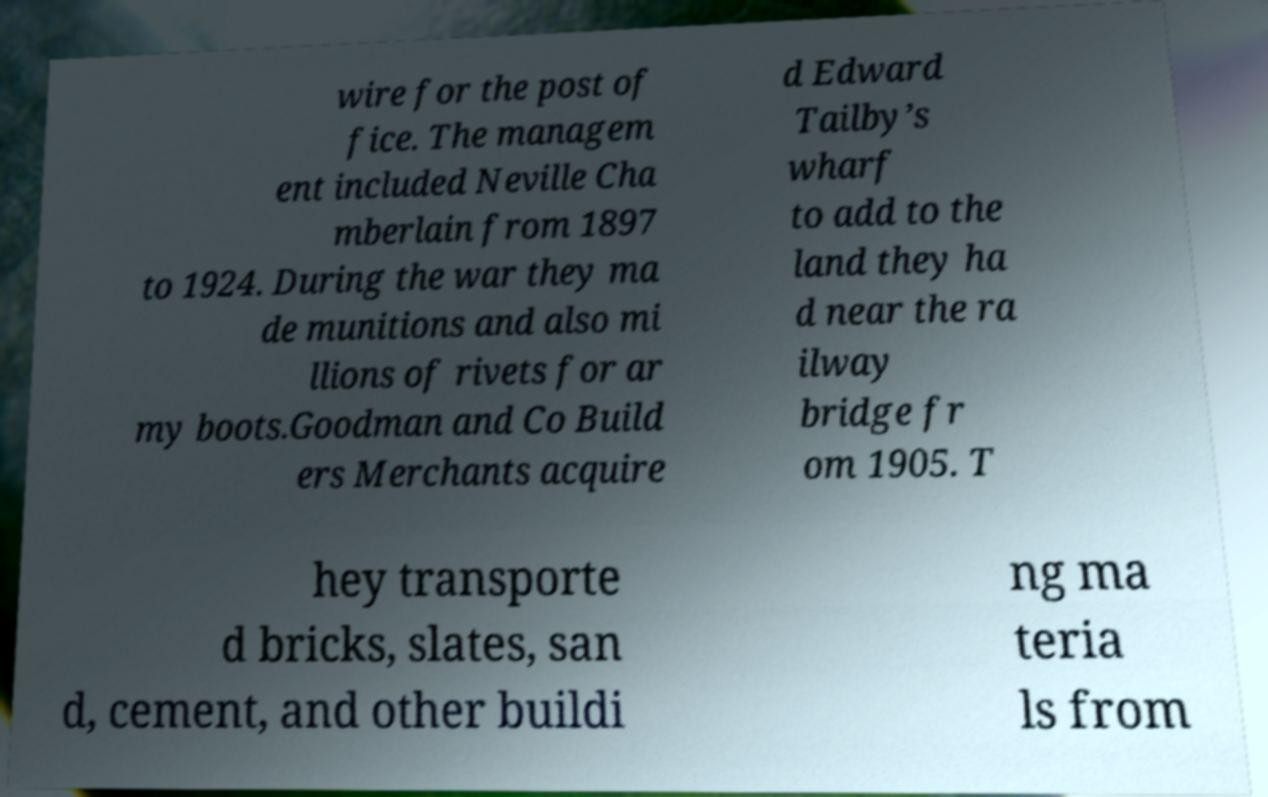Please identify and transcribe the text found in this image. wire for the post of fice. The managem ent included Neville Cha mberlain from 1897 to 1924. During the war they ma de munitions and also mi llions of rivets for ar my boots.Goodman and Co Build ers Merchants acquire d Edward Tailby’s wharf to add to the land they ha d near the ra ilway bridge fr om 1905. T hey transporte d bricks, slates, san d, cement, and other buildi ng ma teria ls from 